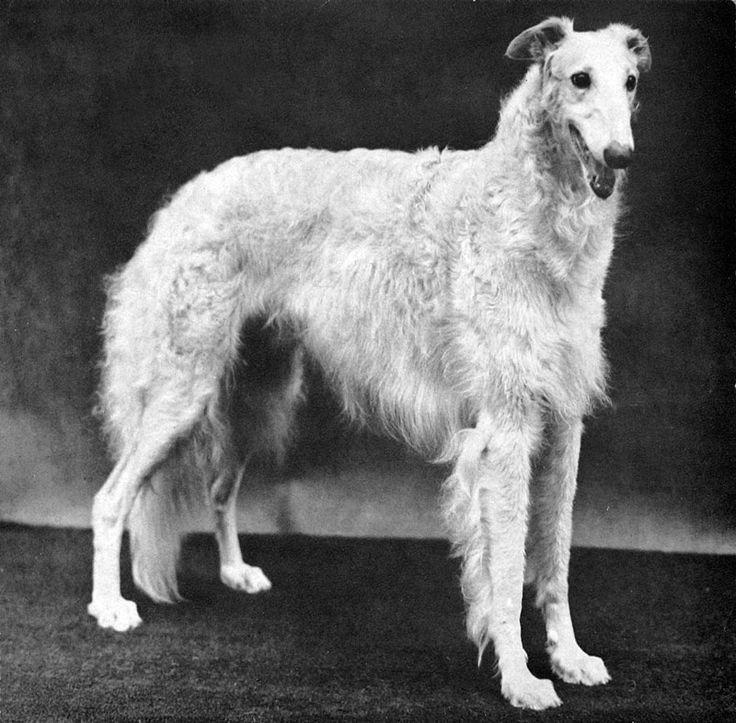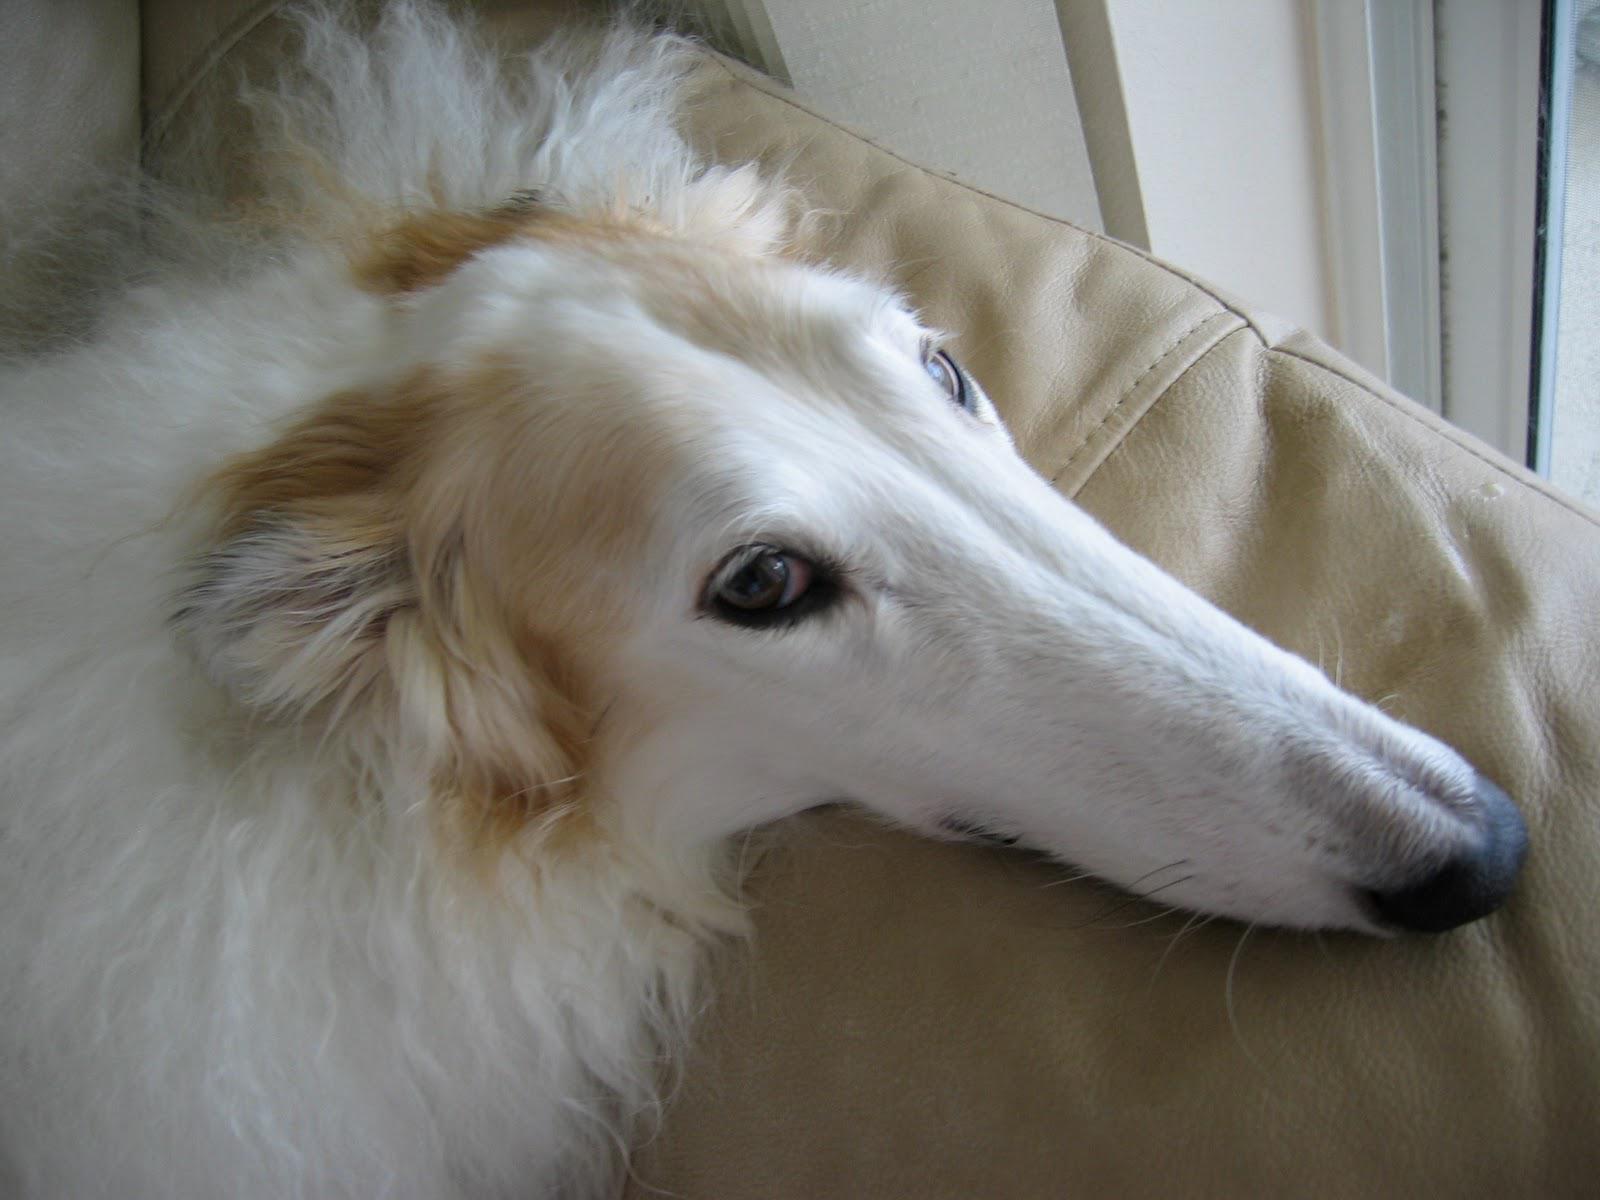The first image is the image on the left, the second image is the image on the right. Analyze the images presented: Is the assertion "An image shows one hound standing still with its body in profile and tail hanging down." valid? Answer yes or no. Yes. The first image is the image on the left, the second image is the image on the right. Considering the images on both sides, is "Two white pointy nosed dogs are shown." valid? Answer yes or no. Yes. 